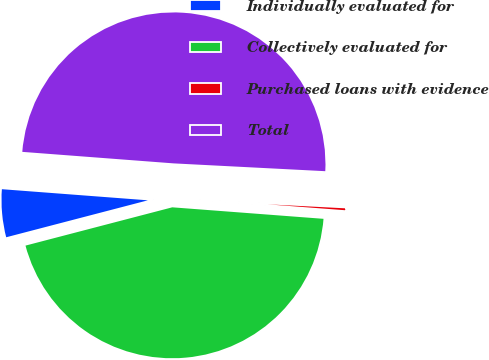Convert chart. <chart><loc_0><loc_0><loc_500><loc_500><pie_chart><fcel>Individually evaluated for<fcel>Collectively evaluated for<fcel>Purchased loans with evidence<fcel>Total<nl><fcel>5.27%<fcel>44.73%<fcel>0.39%<fcel>49.61%<nl></chart> 